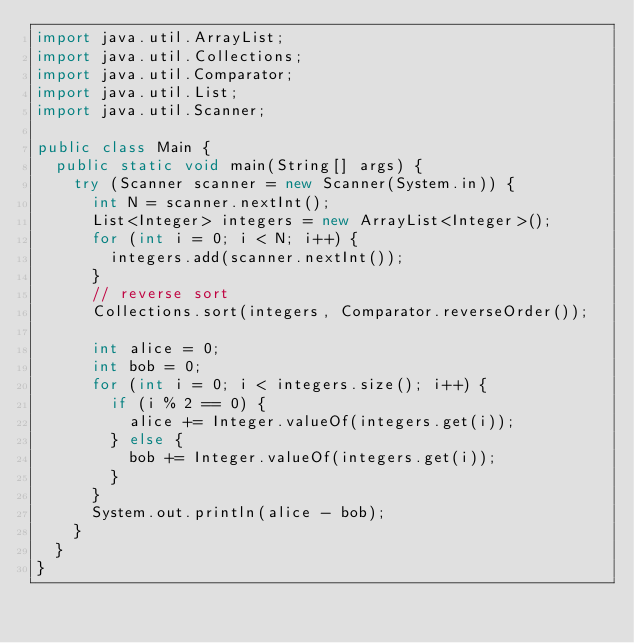<code> <loc_0><loc_0><loc_500><loc_500><_Java_>import java.util.ArrayList;
import java.util.Collections;
import java.util.Comparator;
import java.util.List;
import java.util.Scanner;

public class Main {
	public static void main(String[] args) {
		try (Scanner scanner = new Scanner(System.in)) {
			int N = scanner.nextInt();
			List<Integer> integers = new ArrayList<Integer>();
			for (int i = 0; i < N; i++) {
				integers.add(scanner.nextInt());
			}
			// reverse sort
			Collections.sort(integers, Comparator.reverseOrder());

			int alice = 0;
			int bob = 0;
			for (int i = 0; i < integers.size(); i++) {
				if (i % 2 == 0) {
					alice += Integer.valueOf(integers.get(i));
				} else {
					bob += Integer.valueOf(integers.get(i));
				}
			}
			System.out.println(alice - bob);
		}
	}
}</code> 